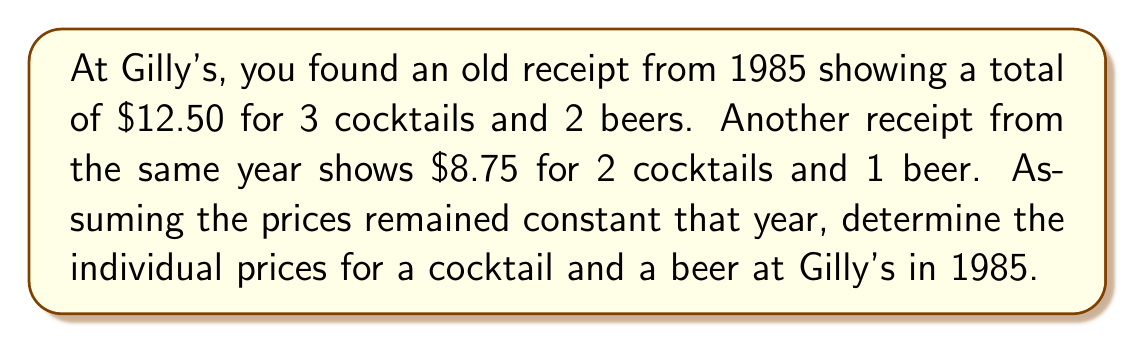Can you answer this question? Let's approach this step-by-step using a system of linear equations:

1) Let $x$ be the price of a cocktail and $y$ be the price of a beer.

2) From the first receipt, we can write:
   $$3x + 2y = 12.50 \quad \text{(Equation 1)}$$

3) From the second receipt:
   $$2x + y = 8.75 \quad \text{(Equation 2)}$$

4) To solve this system, let's use substitution. Multiply Equation 2 by 2:
   $$4x + 2y = 17.50 \quad \text{(Equation 3)}$$

5) Subtract Equation 1 from Equation 3:
   $$x = 5.00$$

6) Substitute this value of $x$ into Equation 2:
   $$2(5.00) + y = 8.75$$
   $$10 + y = 8.75$$
   $$y = -1.25$$

7) Therefore, a cocktail cost $5.00 and a beer cost $1.25 at Gilly's in 1985.
Answer: Cocktail: $5.00, Beer: $1.25 